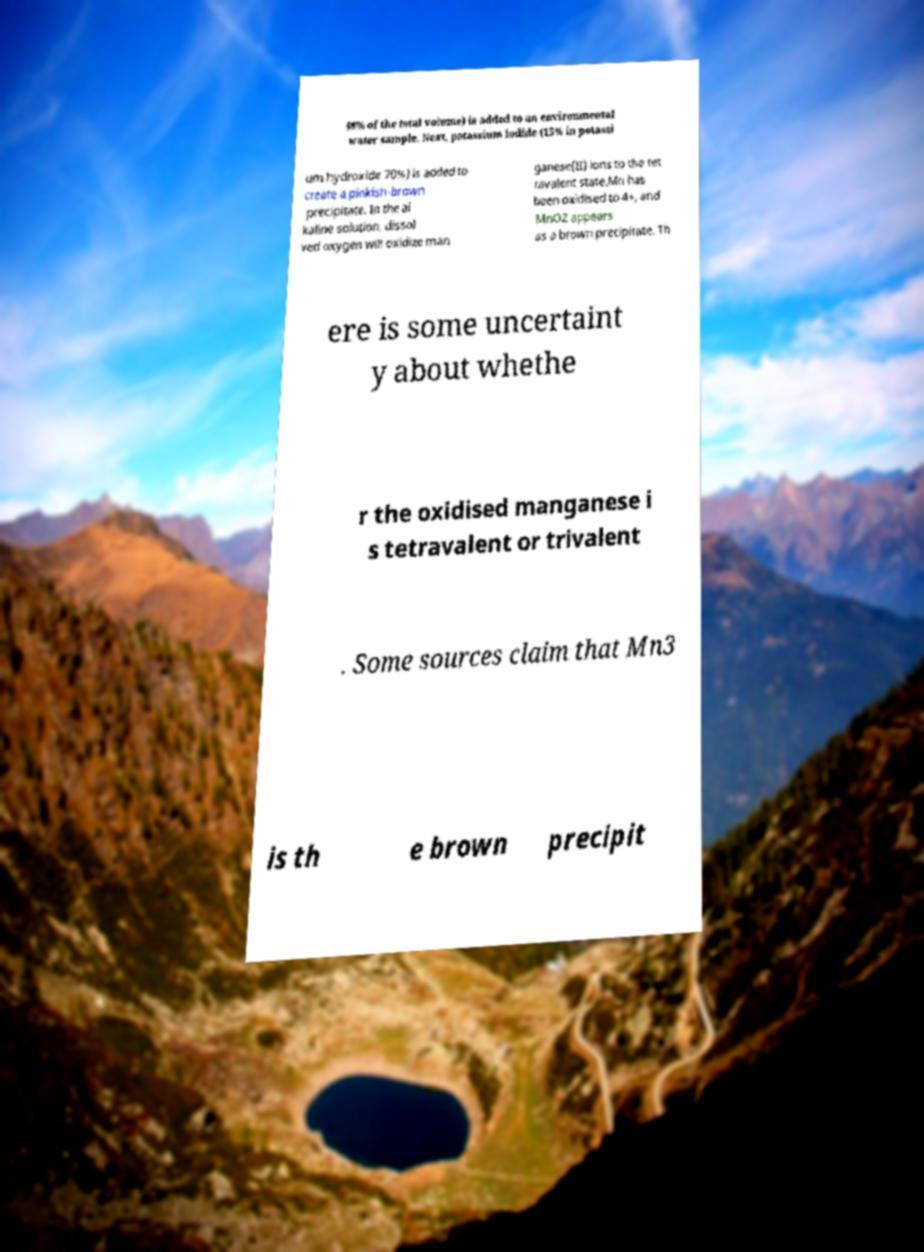Please identify and transcribe the text found in this image. 48% of the total volume) is added to an environmental water sample. Next, potassium iodide (15% in potassi um hydroxide 70%) is added to create a pinkish-brown precipitate. In the al kaline solution, dissol ved oxygen will oxidize man ganese(II) ions to the tet ravalent state.Mn has been oxidised to 4+, and MnO2 appears as a brown precipitate. Th ere is some uncertaint y about whethe r the oxidised manganese i s tetravalent or trivalent . Some sources claim that Mn3 is th e brown precipit 